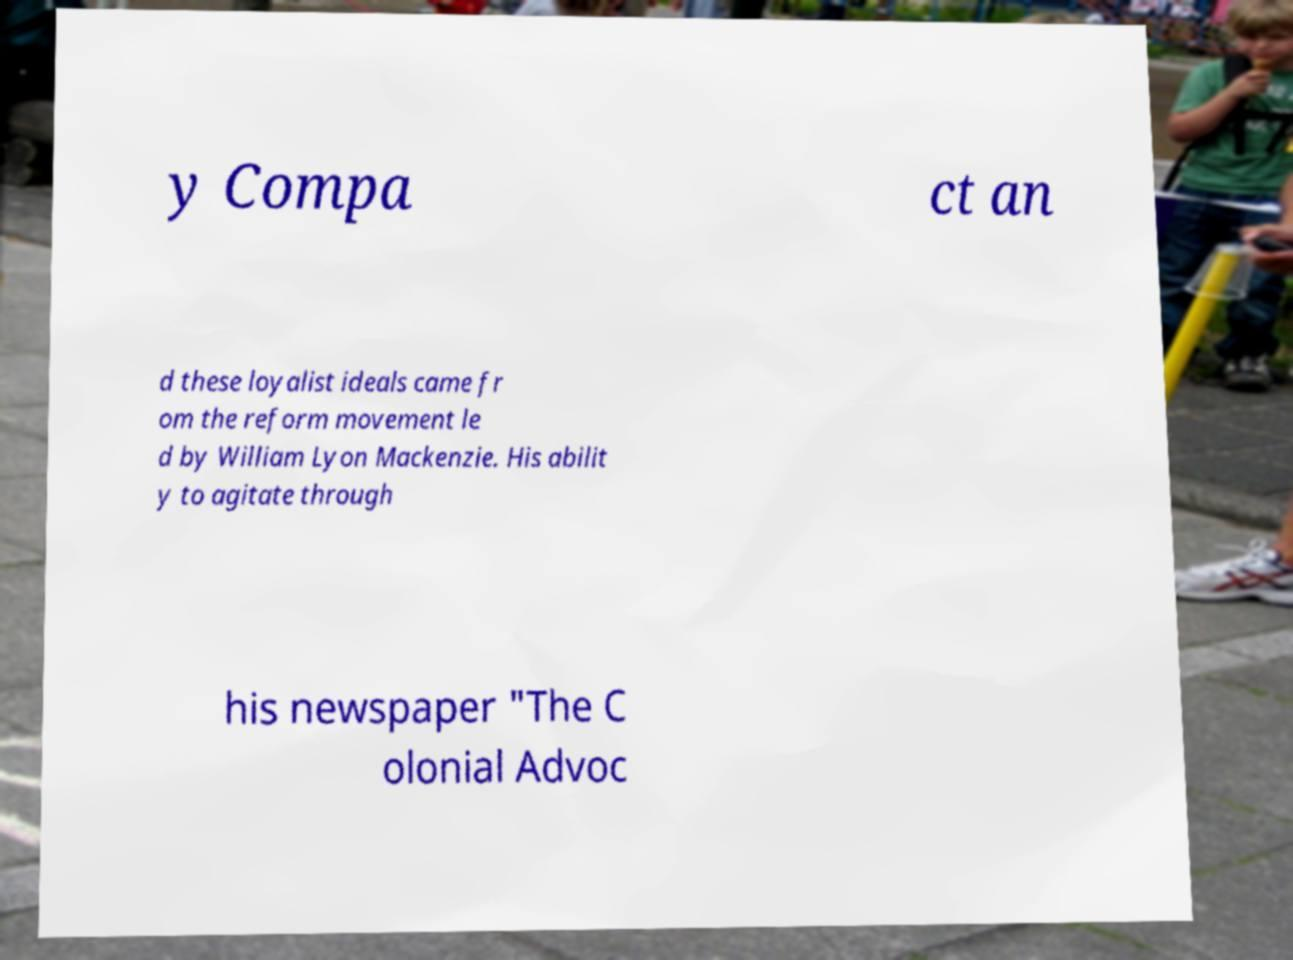Could you assist in decoding the text presented in this image and type it out clearly? y Compa ct an d these loyalist ideals came fr om the reform movement le d by William Lyon Mackenzie. His abilit y to agitate through his newspaper "The C olonial Advoc 